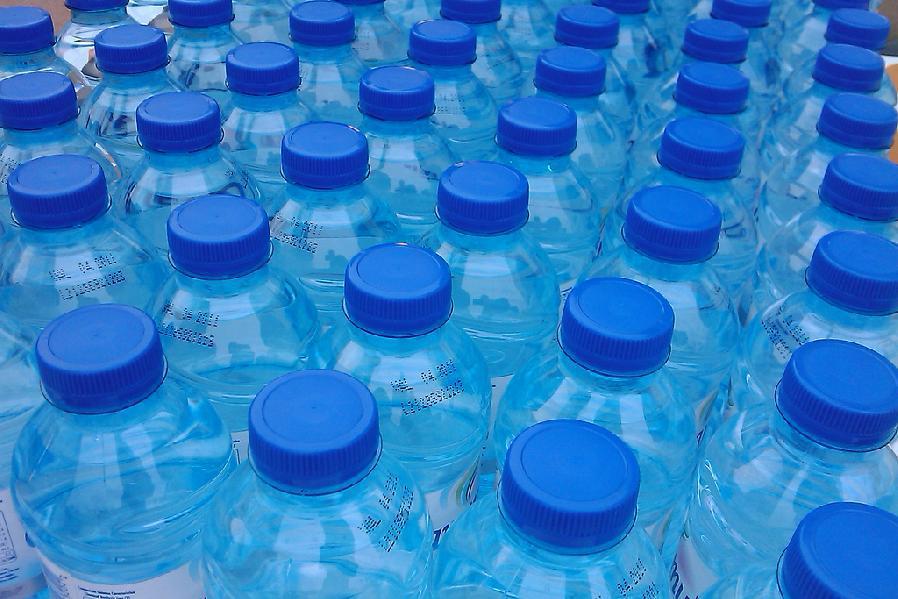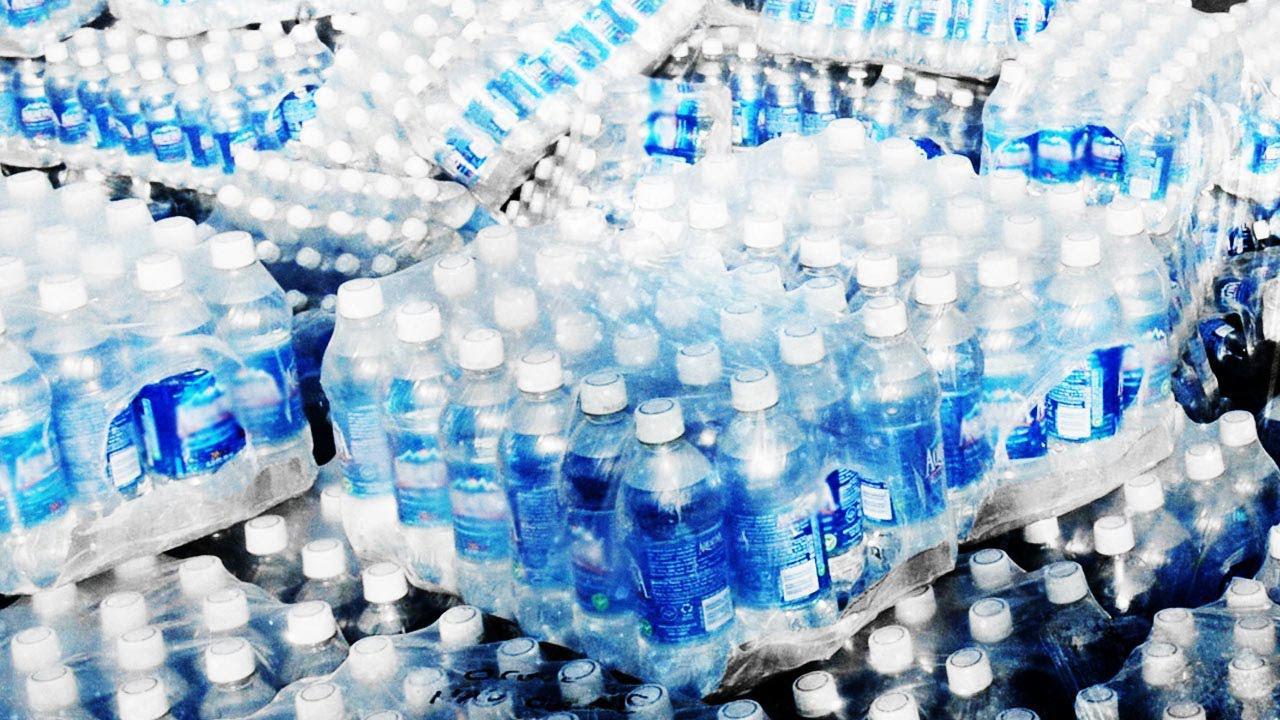The first image is the image on the left, the second image is the image on the right. For the images displayed, is the sentence "the white capped bottles in the image on the right are sealed in packages of at least 16" factually correct? Answer yes or no. Yes. The first image is the image on the left, the second image is the image on the right. Given the left and right images, does the statement "At least one image shows stacked plastic-wrapped bundles of bottles." hold true? Answer yes or no. Yes. 